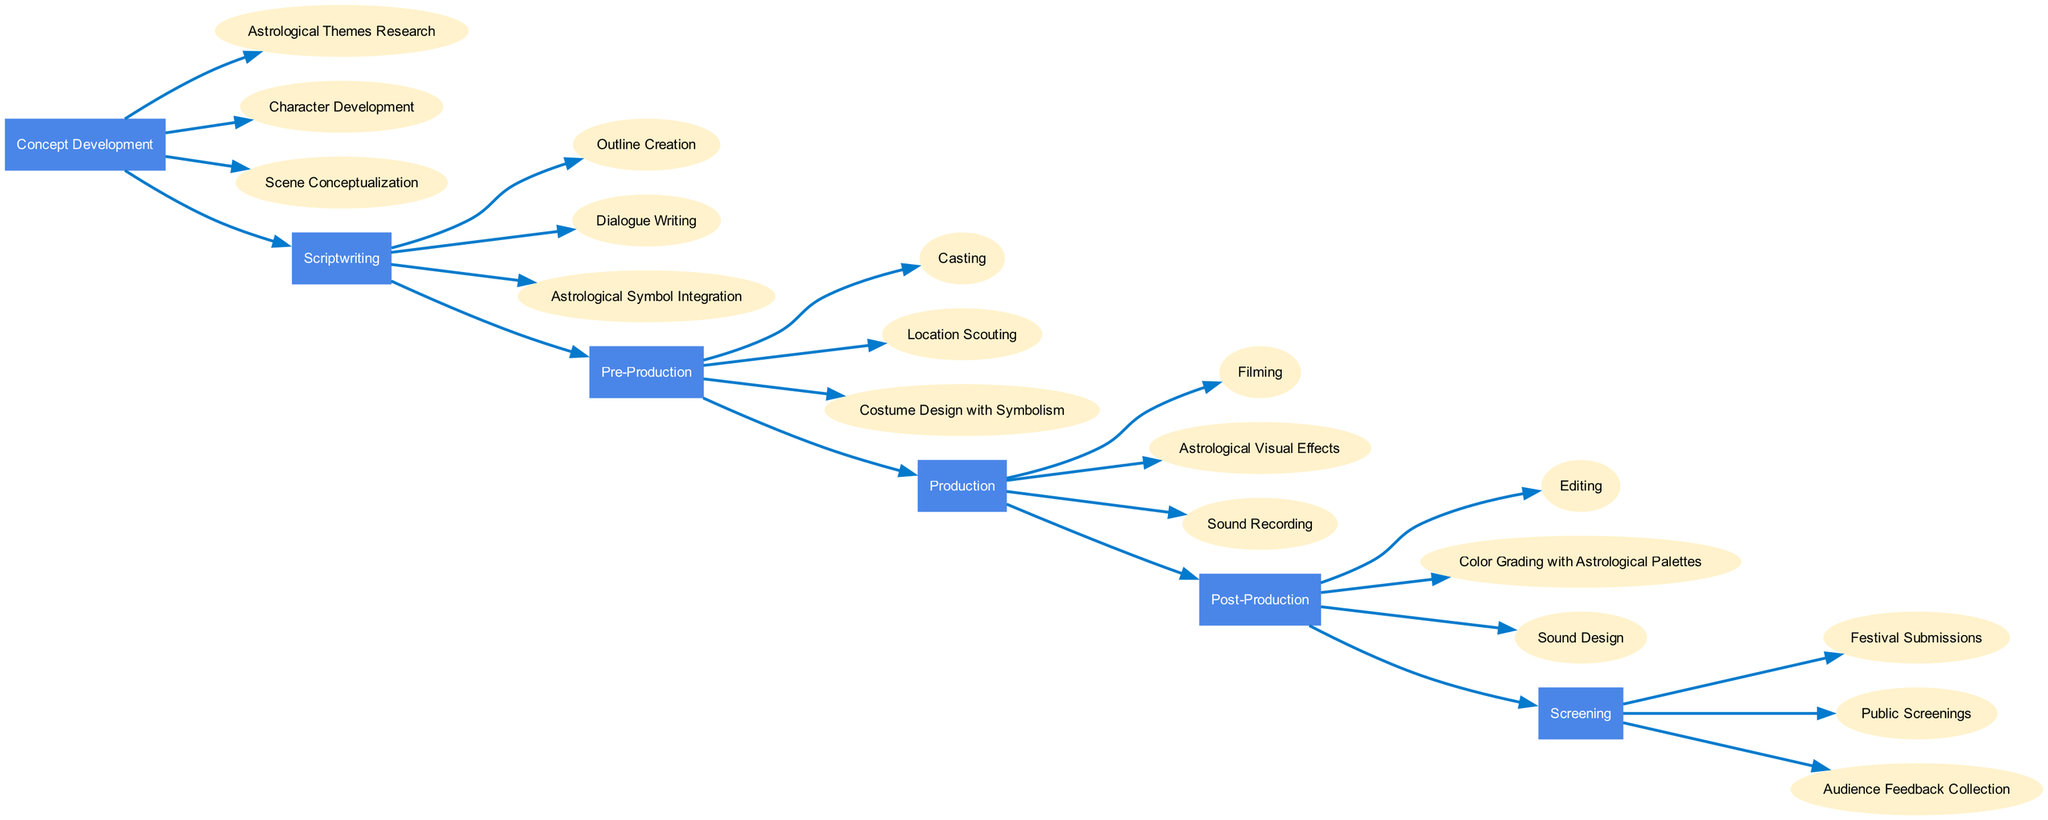What are the sub-elements of the Scriptwriting phase? The Scriptwriting phase has three sub-elements, which are listed directly under it in the diagram: Outline Creation, Dialogue Writing, and Astrological Symbol Integration.
Answer: Outline Creation, Dialogue Writing, Astrological Symbol Integration How many phases are there in total? The diagram has six phases listed in it: Concept Development, Scriptwriting, Pre-Production, Production, Post-Production, and Screening. To get this total, I counted each separate phase shown in the diagram.
Answer: 6 Which phase includes Audience Feedback Collection? Audience Feedback Collection is a sub-element within the Screening phase, which can be identified by tracing the edges leading to the relevant sub-elements.
Answer: Screening What are the sub-elements of the Pre-Production phase? The Pre-Production phase includes three sub-elements: Casting, Location Scouting, and Costume Design with Symbolism. These can be found listed under the Pre-Production phase in the diagram.
Answer: Casting, Location Scouting, Costume Design with Symbolism How does the Production phase relate to the Post-Production phase? The Production phase connects to the Post-Production phase via a directed edge, which indicates the flow from one phase to the next. Each phase is sequentially connected to signify the order of the filmmaking process.
Answer: Directed edge Which phase comes after Concept Development? The phase that comes after Concept Development is Scriptwriting, as indicated by the progression of phases in the diagram. The arrows show the direction of flow from one phase to the next.
Answer: Scriptwriting Which element includes Color Grading with Astrological Palettes? Color Grading with Astrological Palettes is a sub-element of the Post-Production phase. It is found listed among other sub-elements under Post-Production in the diagram.
Answer: Post-Production What is the last phase in the filmmaking process flowchart? The last phase in the flowchart is Screening, which is positioned at the far right of the diagram and does not lead to any further phases, indicating it is the final step.
Answer: Screening 